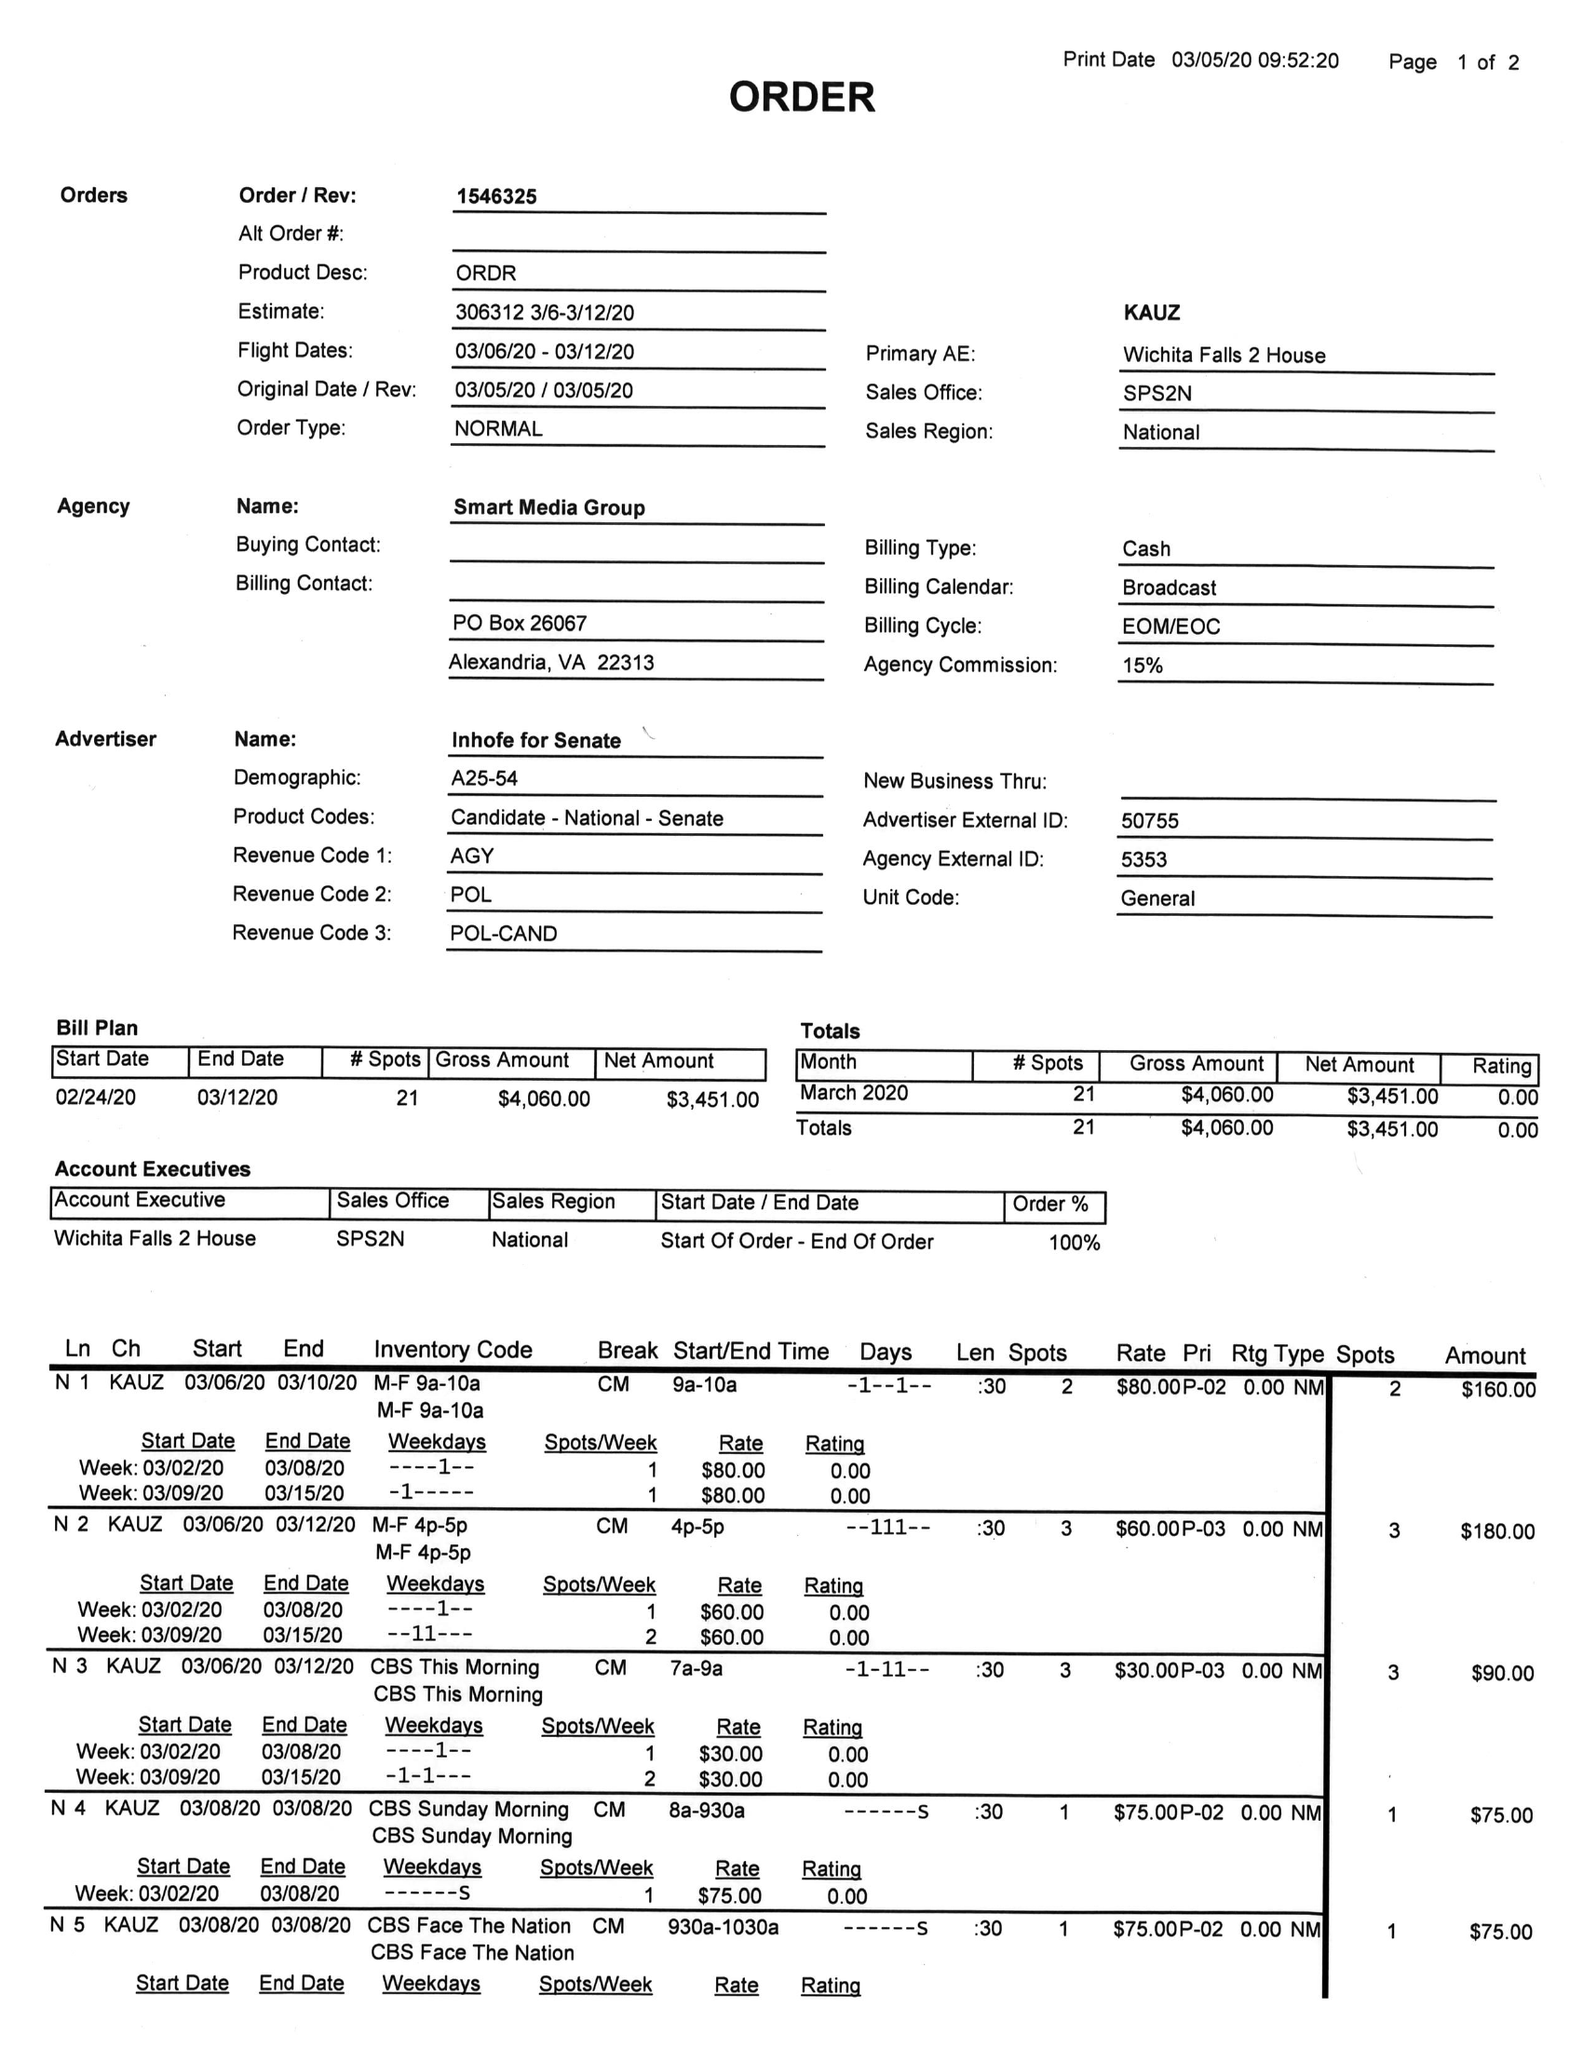What is the value for the contract_num?
Answer the question using a single word or phrase. 1546325 